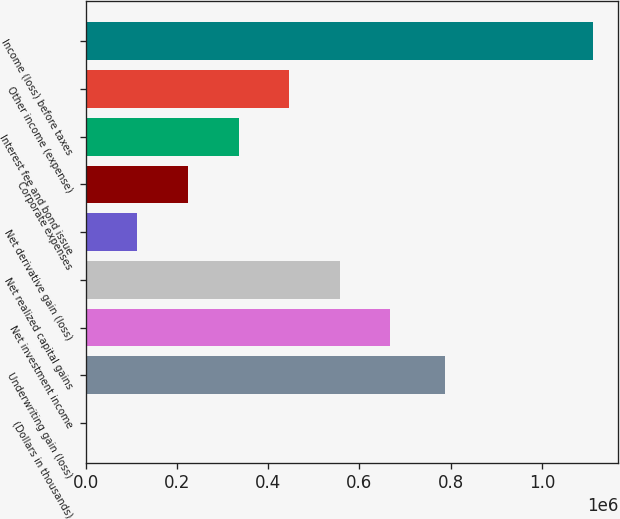Convert chart to OTSL. <chart><loc_0><loc_0><loc_500><loc_500><bar_chart><fcel>(Dollars in thousands)<fcel>Underwriting gain (loss)<fcel>Net investment income<fcel>Net realized capital gains<fcel>Net derivative gain (loss)<fcel>Corporate expenses<fcel>Interest fee and bond issue<fcel>Other income (expense)<fcel>Income (loss) before taxes<nl><fcel>2015<fcel>787412<fcel>667940<fcel>556952<fcel>113002<fcel>223990<fcel>334978<fcel>445965<fcel>1.11189e+06<nl></chart> 